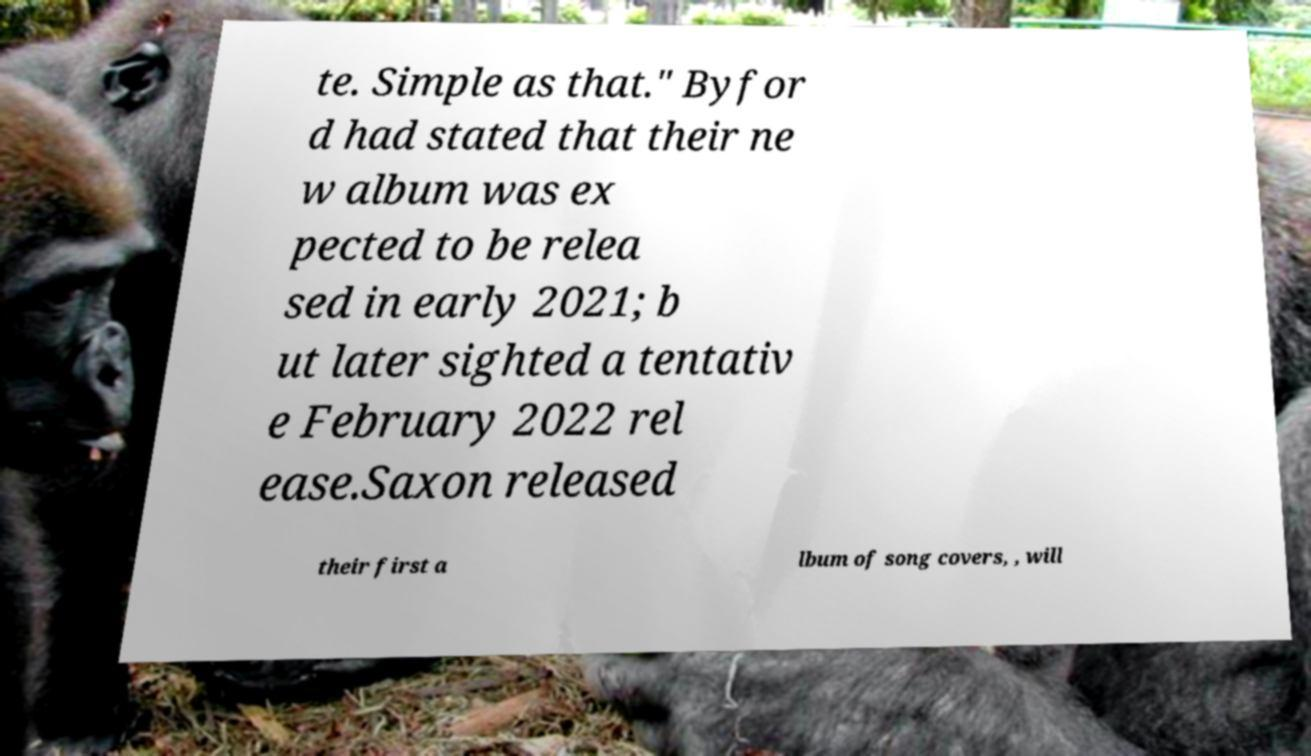What messages or text are displayed in this image? I need them in a readable, typed format. te. Simple as that." Byfor d had stated that their ne w album was ex pected to be relea sed in early 2021; b ut later sighted a tentativ e February 2022 rel ease.Saxon released their first a lbum of song covers, , will 